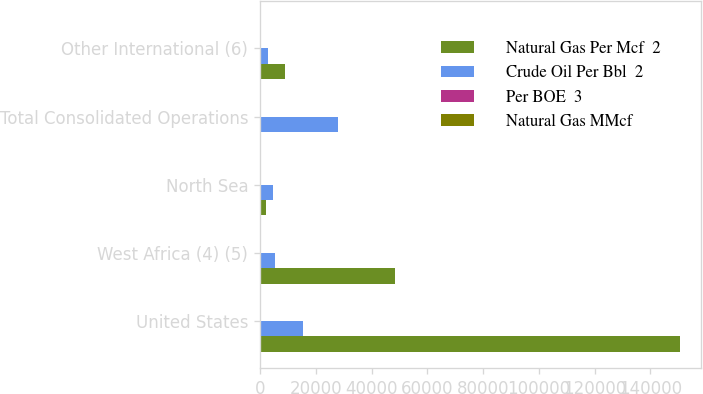Convert chart. <chart><loc_0><loc_0><loc_500><loc_500><stacked_bar_chart><ecel><fcel>United States<fcel>West Africa (4) (5)<fcel>North Sea<fcel>Total Consolidated Operations<fcel>Other International (6)<nl><fcel>Natural Gas Per Mcf  2<fcel>150457<fcel>48349<fcel>2276<fcel>76.47<fcel>9041<nl><fcel>Crude Oil Per Bbl  2<fcel>15451<fcel>5500<fcel>4564<fcel>27951<fcel>2752<nl><fcel>Per BOE  3<fcel>7.51<fcel>0.29<fcel>6.54<fcel>5.26<fcel>0.96<nl><fcel>Natural Gas MMcf<fcel>53.22<fcel>71.27<fcel>76.47<fcel>60.61<fcel>52.05<nl></chart> 